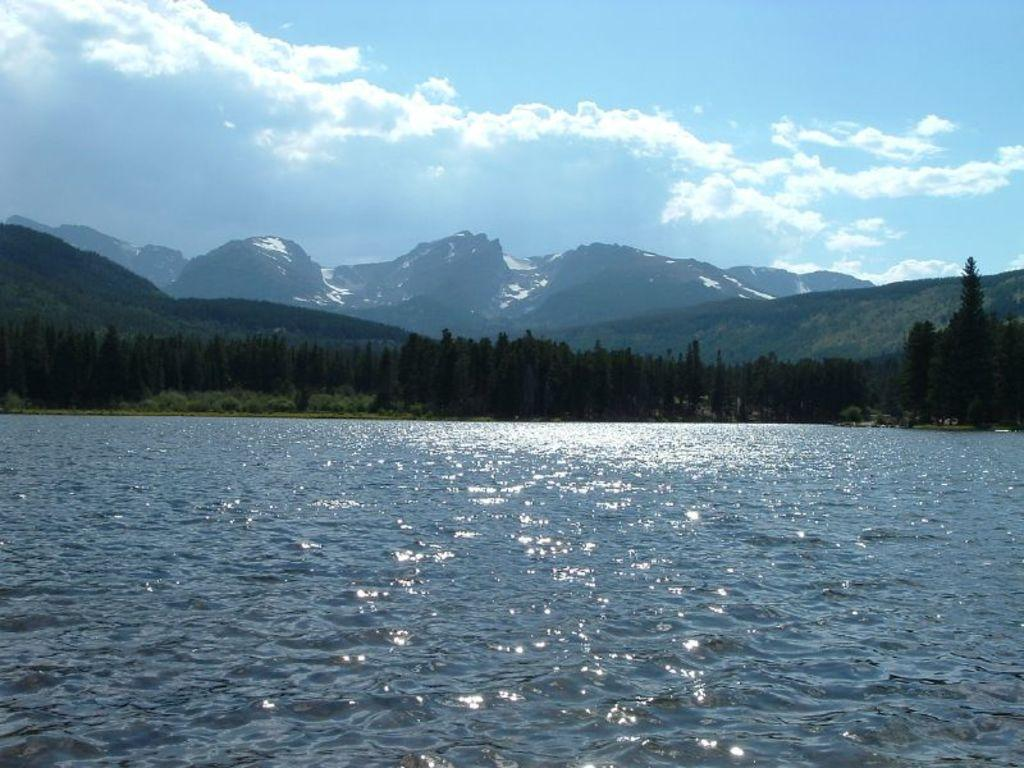What is the primary element visible in the image? There is water in the image. What type of vegetation can be seen in the image? There are trees in the image. What geographical feature is present in the image? There are mountains in the image. What is visible in the background of the image? The sky is visible in the background of the image. What can be observed in the sky? Clouds are present in the sky. Can you tell me how many ears of corn are growing in the water? There is no corn present in the image; it features water, trees, mountains, and clouds. 